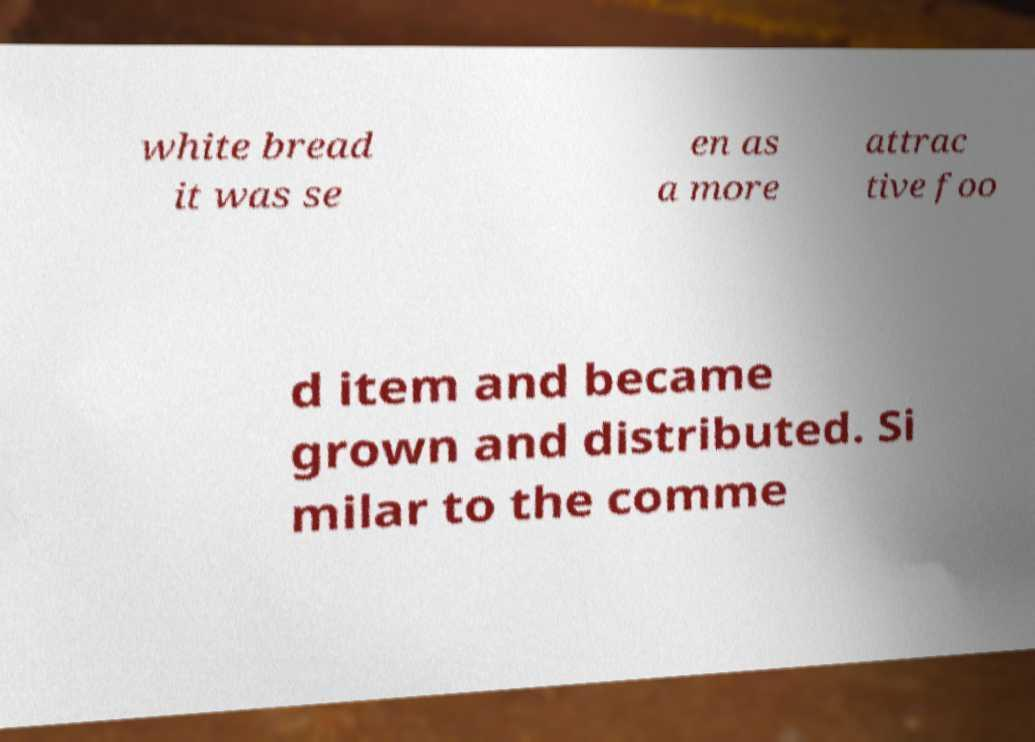Could you extract and type out the text from this image? white bread it was se en as a more attrac tive foo d item and became grown and distributed. Si milar to the comme 